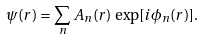Convert formula to latex. <formula><loc_0><loc_0><loc_500><loc_500>\psi ( { r } ) = \sum _ { n } A _ { n } ( { r } ) \, \exp [ i \phi _ { n } ( { r } ) ] .</formula> 